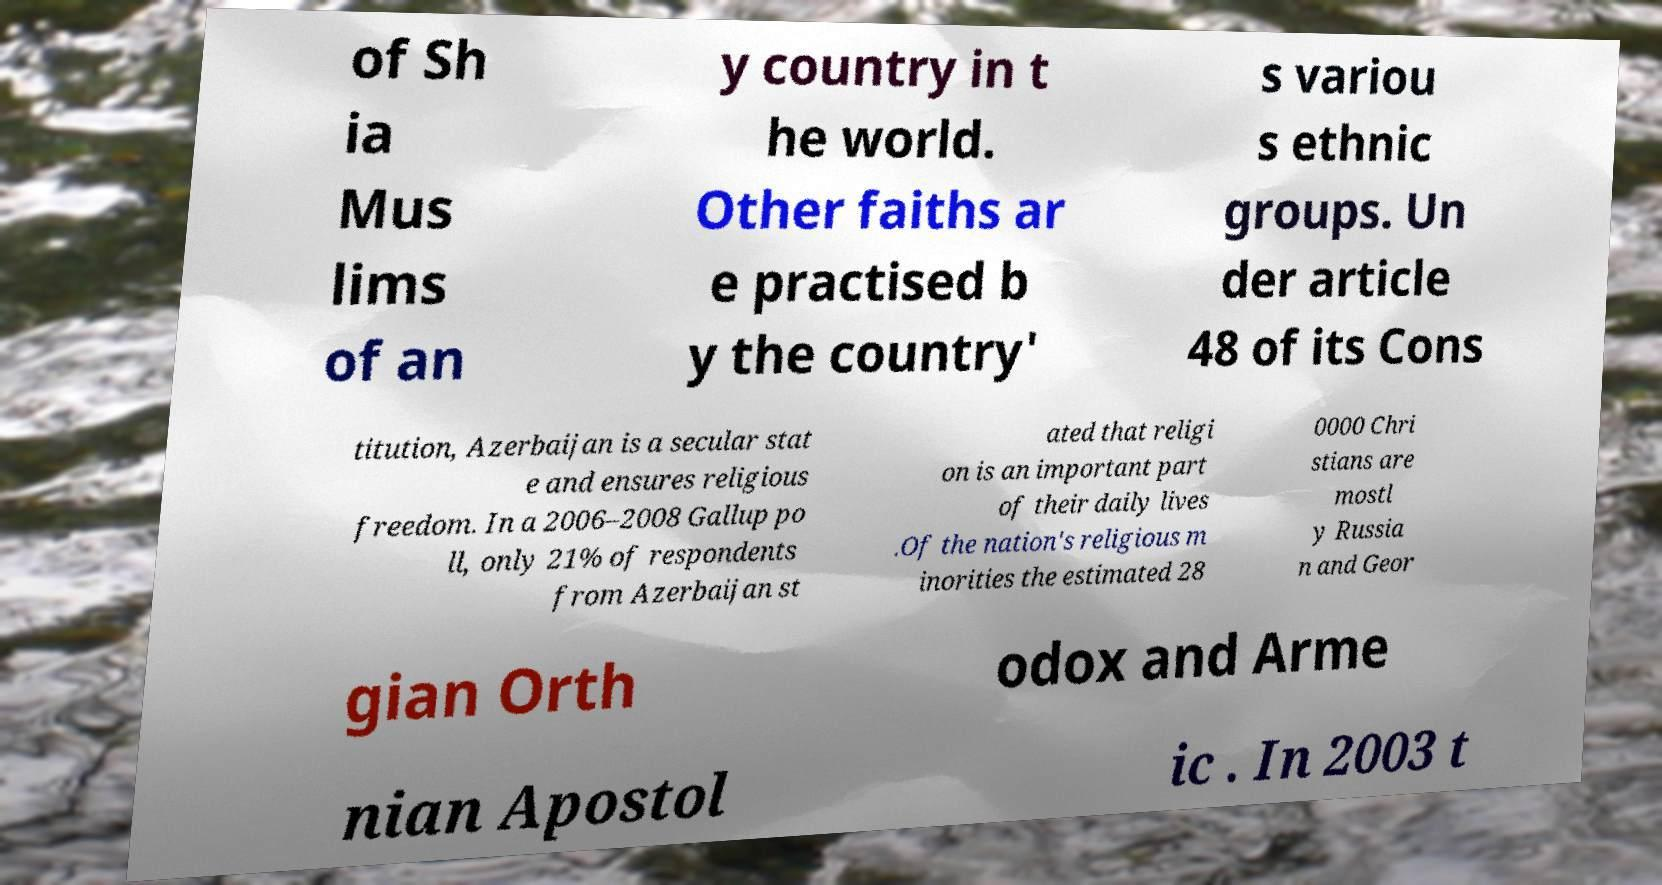There's text embedded in this image that I need extracted. Can you transcribe it verbatim? of Sh ia Mus lims of an y country in t he world. Other faiths ar e practised b y the country' s variou s ethnic groups. Un der article 48 of its Cons titution, Azerbaijan is a secular stat e and ensures religious freedom. In a 2006–2008 Gallup po ll, only 21% of respondents from Azerbaijan st ated that religi on is an important part of their daily lives .Of the nation's religious m inorities the estimated 28 0000 Chri stians are mostl y Russia n and Geor gian Orth odox and Arme nian Apostol ic . In 2003 t 